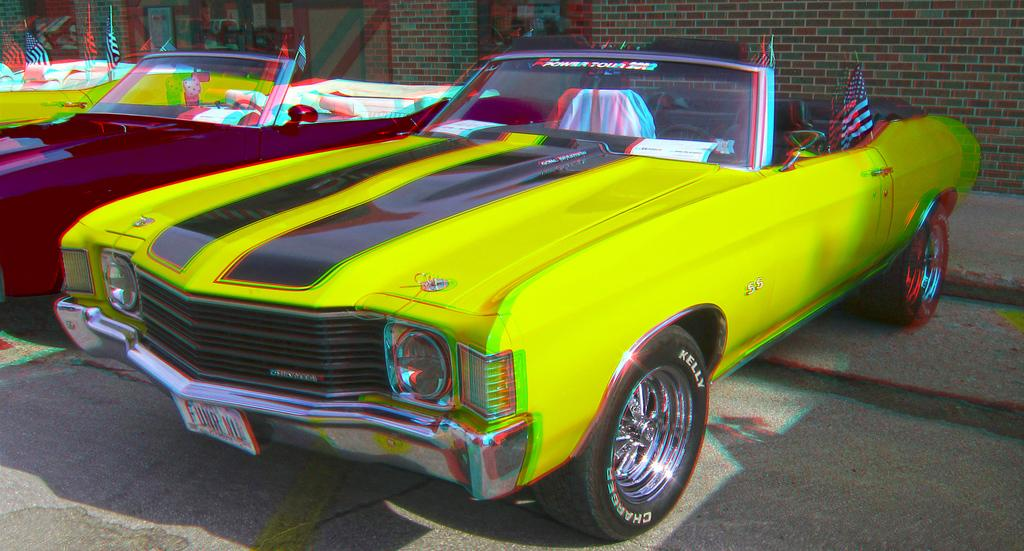What type of vehicles can be seen on the road in the image? There are cars on the road in the image. What is visible in the background of the image? There is a wall in the background of the image. What type of wine is being served at the experience depicted in the image? There is no experience or wine present in the image; it only features cars on the road and a wall in the background. 